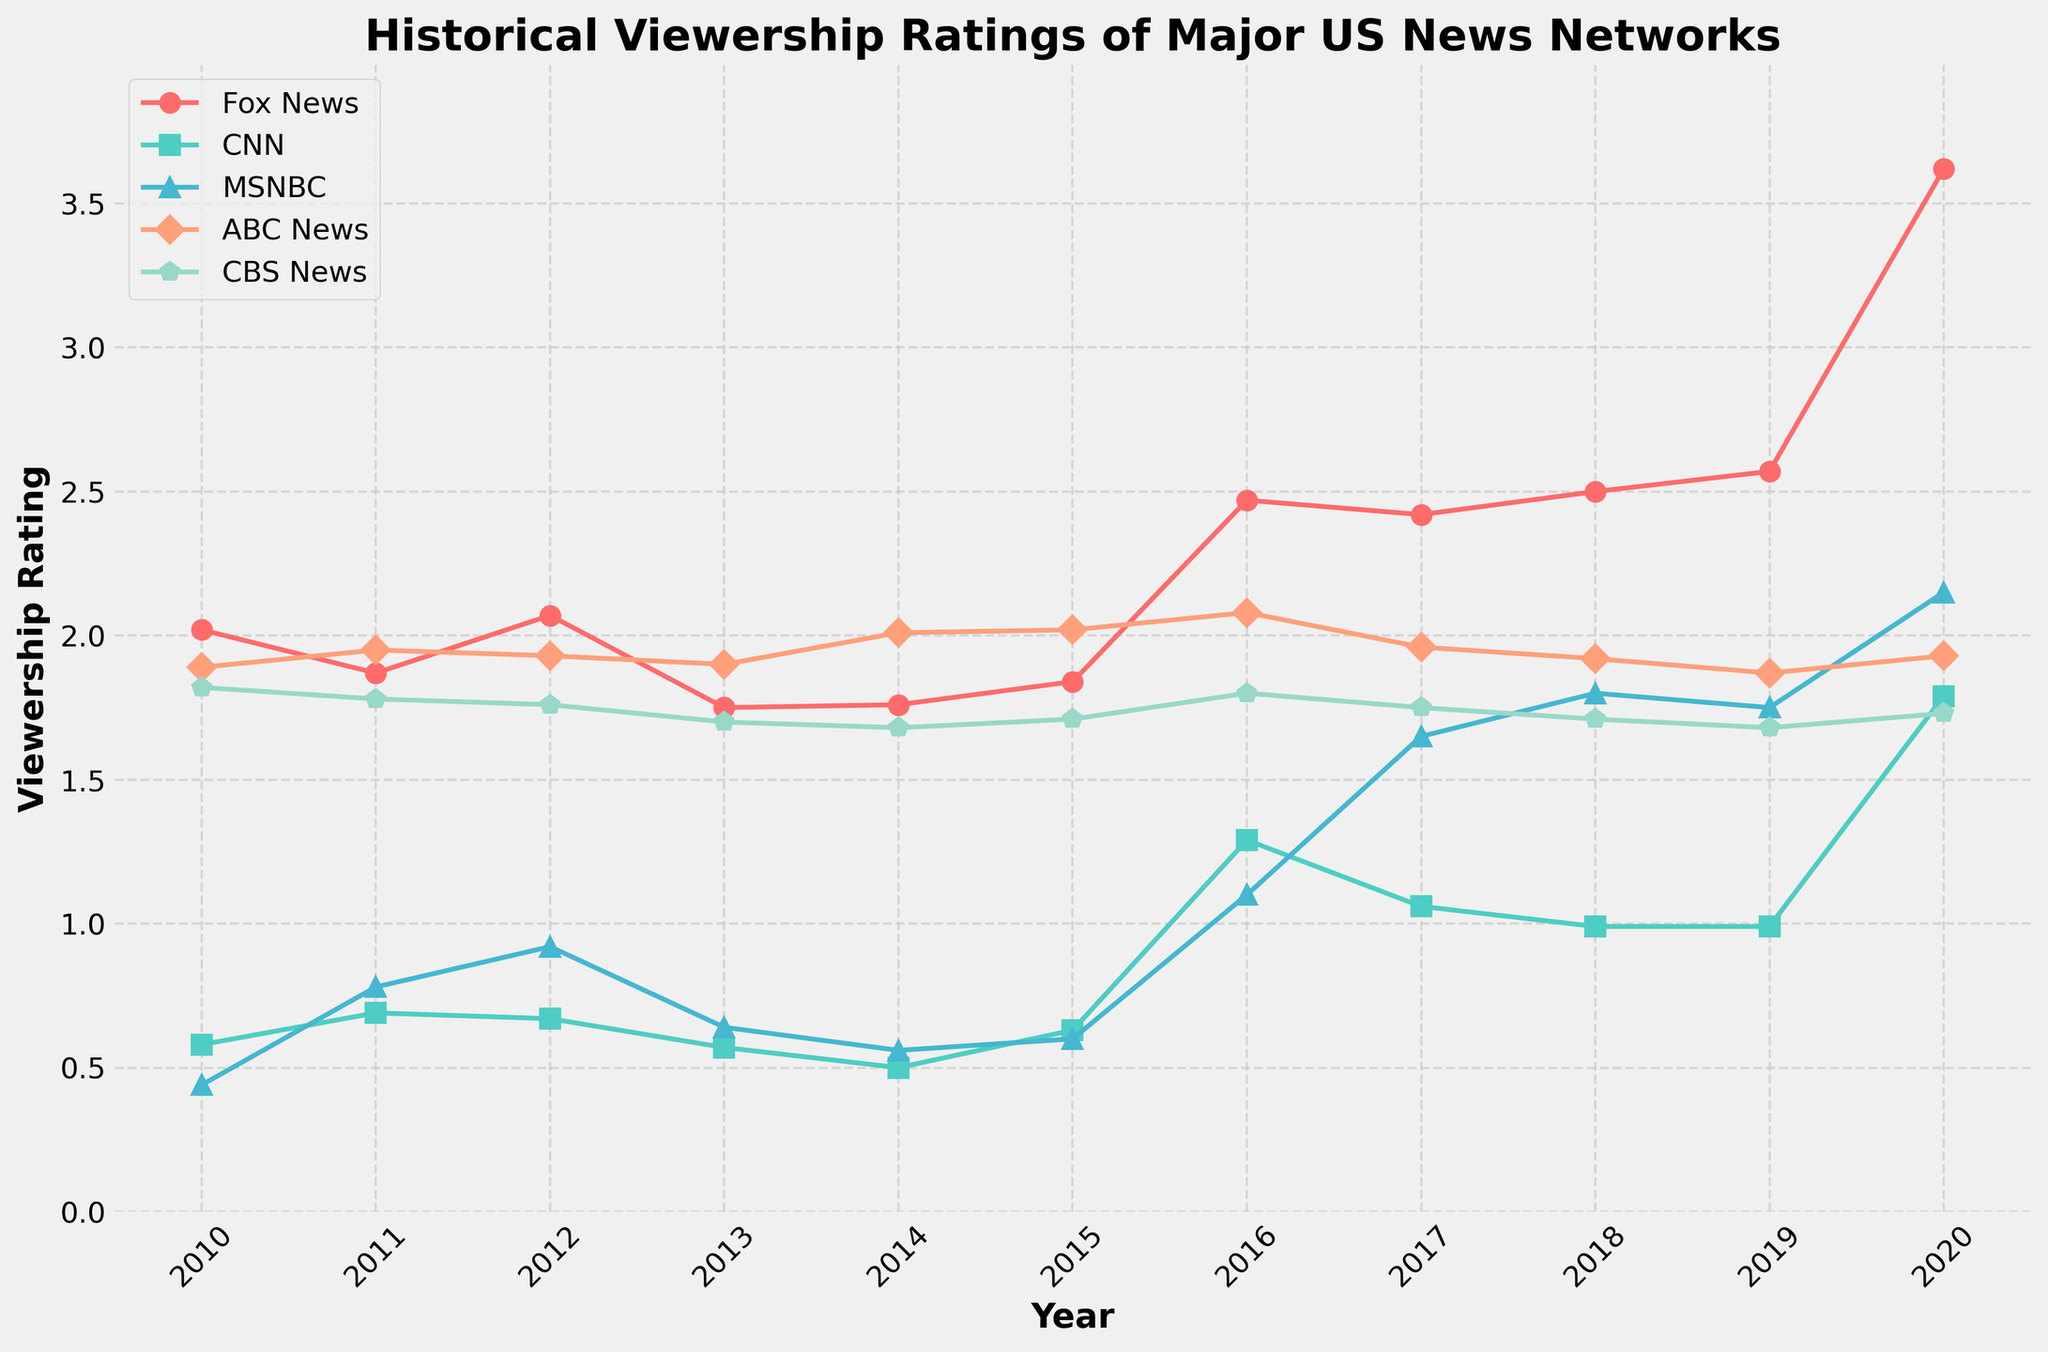Which news network had the highest viewership rating in 2020? Look for the highest data point in 2020 across all lines in the chart. Fox News has the highest peak.
Answer: Fox News How did CNN's viewership rating change between 2016 and 2017? Compare CNN's viewership rating in both years. It dropped from 1.29 to 1.06.
Answer: Decreased What is the difference in viewership ratings between Fox News and MSNBC in 2020? Identify the ratings of Fox News and MSNBC in 2020, then subtract MSNBC's rating from Fox News' rating: 3.62 - 2.15 = 1.47.
Answer: 1.47 Which liberal-leaning news network saw a steady increase in viewership ratings from 2015 to 2020? Look at the trend lines for CNN and MSNBC from 2015 to 2020. Both increase, but MSNBC’s increase is more notable.
Answer: MSNBC How did ABC News' viewership rating in 2013 compare to its rating in 2020? Compare the ratings of ABC News in both years: 1.90 in 2013 and 1.93 in 2020.
Answer: Slightly increased What is the average viewership rating of CBS News from 2010 to 2020? Add the viewership ratings of CBS News for all years and divide by the number of years: (1.82 + 1.78 + 1.76 + 1.70 + 1.68 + 1.71 + 1.80 + 1.75 + 1.71 + 1.68 + 1.73) / 11 = 1.7446.
Answer: 1.74 Which news network had the lowest viewership rating in 2011? Identify the lowest value among the lines' data points for 2011, which is CNN at 0.69.
Answer: CNN Between 2010 and 2020, which news network saw the most significant growth in viewership rating? Look at the change in ratings from 2010 to 2020 for each network. Fox News grew from 2.02 to 3.62, the largest increase.
Answer: Fox News In what year did MSNBC surpass CNN in viewership rating? Track both MSNBC and CNN lines and find the year where MSNBC's rating first becomes greater than CNN's. This happened in 2016.
Answer: 2016 